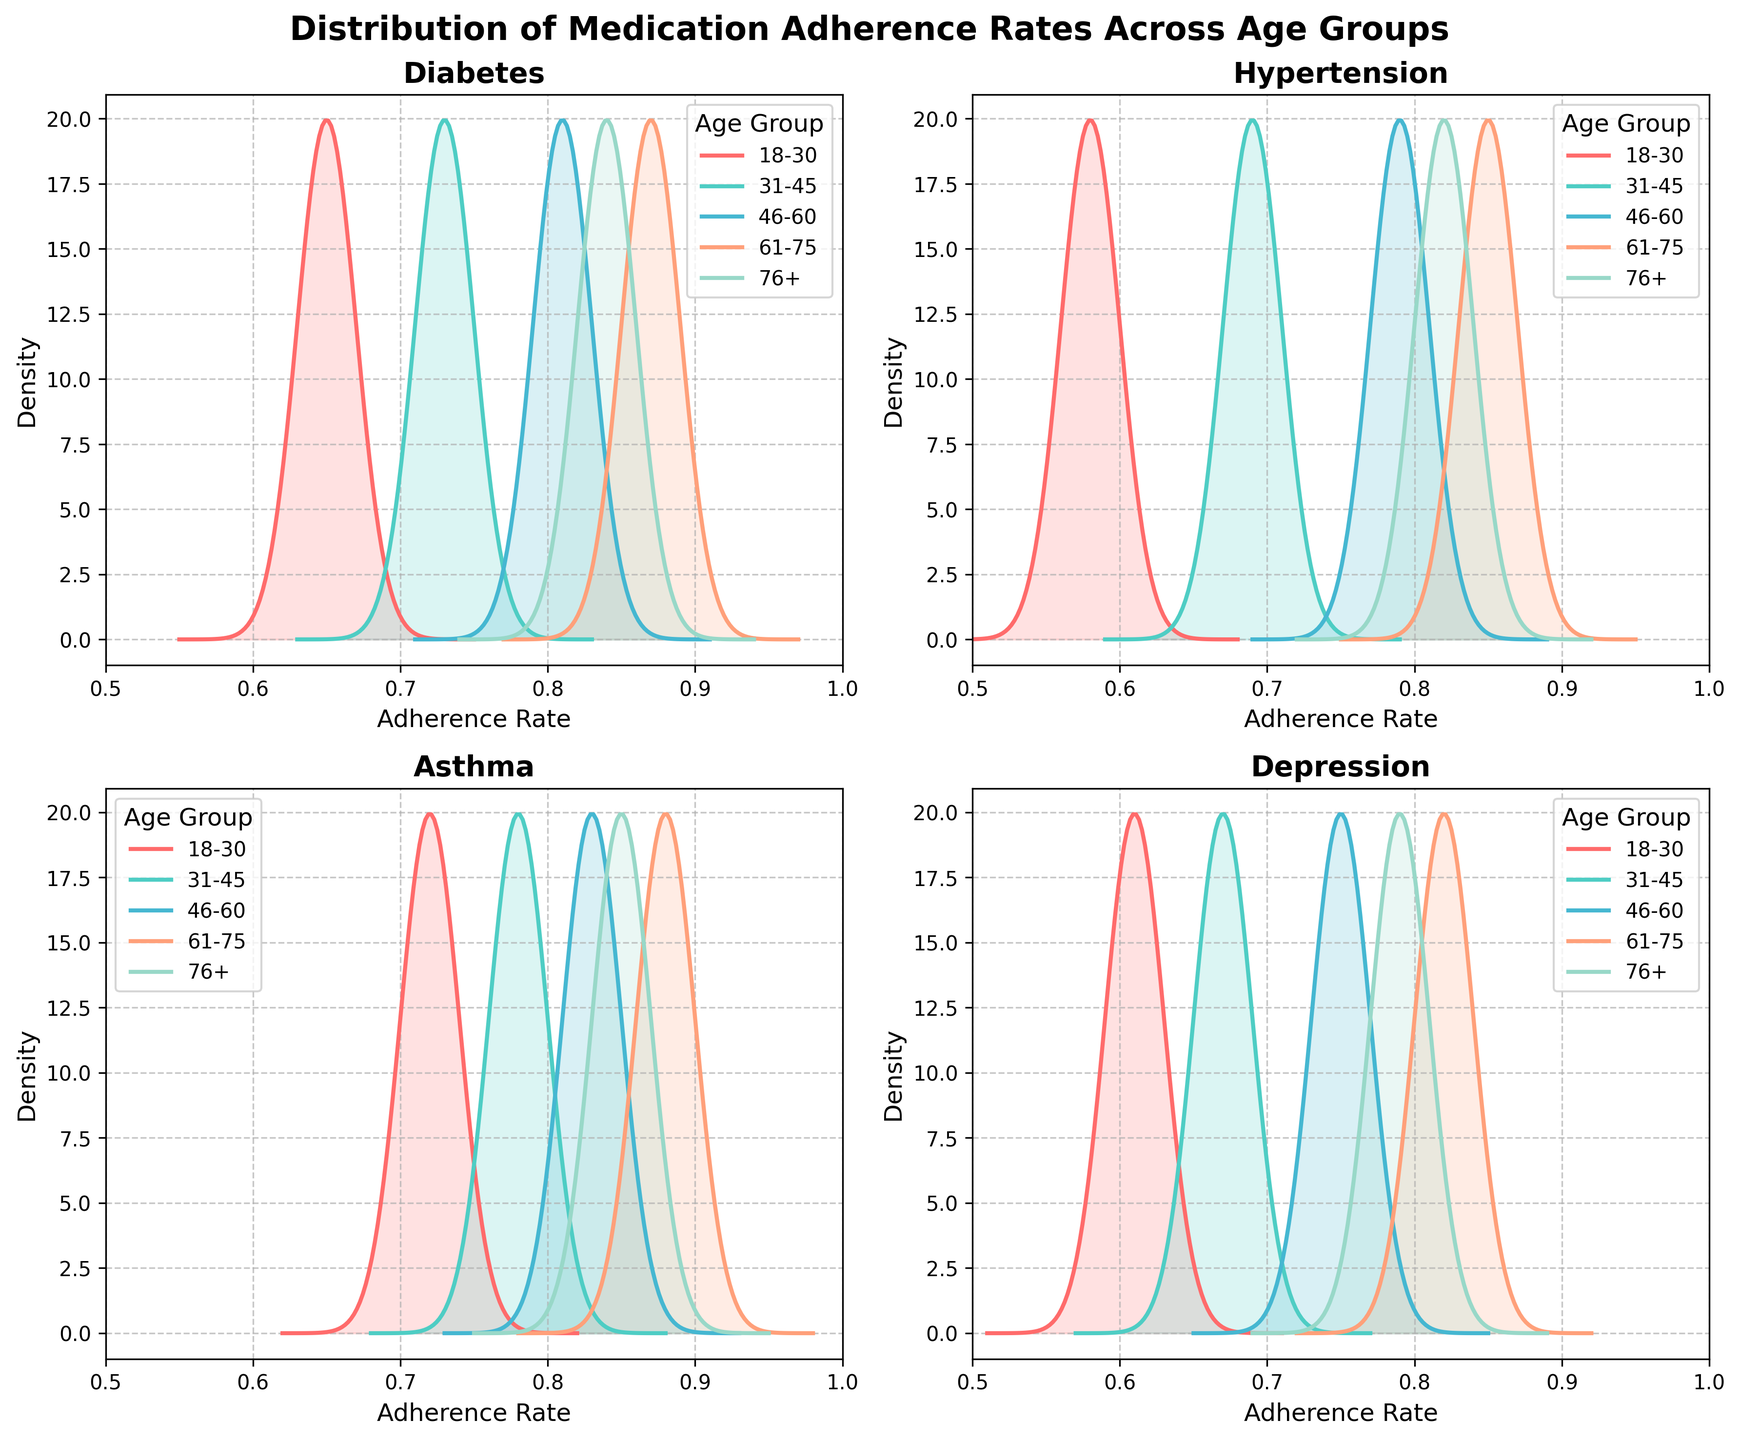What is the title of the figure? The title is positioned at the top of the figure and usually provides a quick summary of what the plot is about.
Answer: Distribution of Medication Adherence Rates Across Age Groups Which condition has the highest adherence rate in the 61-75 age group? Each subplot corresponds to a different condition, and within each subplot, different lines represent different age groups. Look at the 61-75 age group's curve in each subplot to find the highest value.
Answer: Asthma In which condition do the 18-30 age group and the 46-60 age group have almost the same adherence rate? Examine the plots for each condition. Identify where the density curves for the 18-30 and the 46-60 age groups overlap or are very close to each other.
Answer: Depression How does the adherence rate for Hypertension in the 76+ age group compare to that of the 31-45 age group? Look at the density plot for Hypertension and compare the peaks or the highest points of the 76+ and 31-45 age group's curves.
Answer: The 76+ age group has a higher adherence rate than the 31-45 age group What is the range of adherence rates visualized on the x-axis? The x-axis shows the range of adherence rates for all density plots.
Answer: 0.5 to 1.0 Which age group shows the highest density peak for Asthma adherence rates? In the subplot for Asthma, identify the age group with the highest peak value in its density curve.
Answer: 61-75 Are the adherence rates more consistent across age groups for Diabetes or Depression? Compare the density plots for Diabetes and Depression. For more consistency, look for narrower peaks and less spread in the curves across age groups.
Answer: Diabetes Which conditions have higher overall adherence rates as shown by the density plots? Look at all subplots and compare the positions of the density peaks. Higher adherence rates will have density peaks closer to the right side of the x-axis.
Answer: Asthma and Diabetes What's the difference in the adherence rate peaks between the 18-30 and 61-75 age groups for Diabetes? Find the peak values for the 18-30 and 61-75 age groups in the Diabetes subplot and calculate the difference.
Answer: 0.22 For which condition do the adherence rates for all age groups appear to be clustered the closest together? Identify which subplot has the most overlapping and close density curves, indicating clustering.
Answer: Depression 